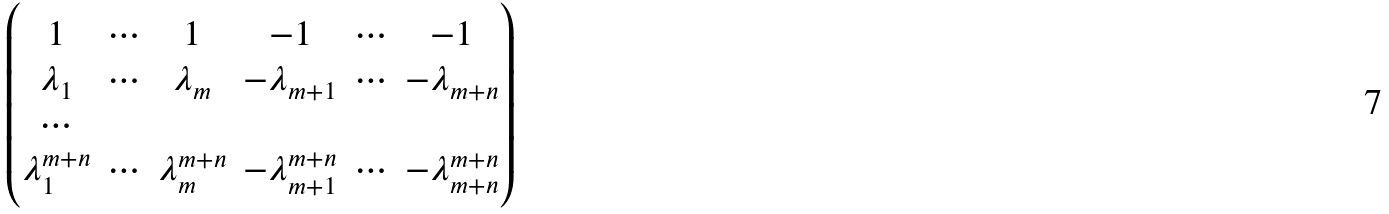<formula> <loc_0><loc_0><loc_500><loc_500>\begin{pmatrix} 1 & \cdots & 1 & - 1 & \cdots & - 1 \\ \lambda _ { 1 } & \cdots & \lambda _ { m } & - \lambda _ { m + 1 } & \cdots & - \lambda _ { m + n } \\ \cdots \\ \lambda _ { 1 } ^ { m + n } & \cdots & \lambda ^ { m + n } _ { m } & - \lambda _ { m + 1 } ^ { m + n } & \cdots & - \lambda ^ { m + n } _ { m + n } \end{pmatrix}</formula> 